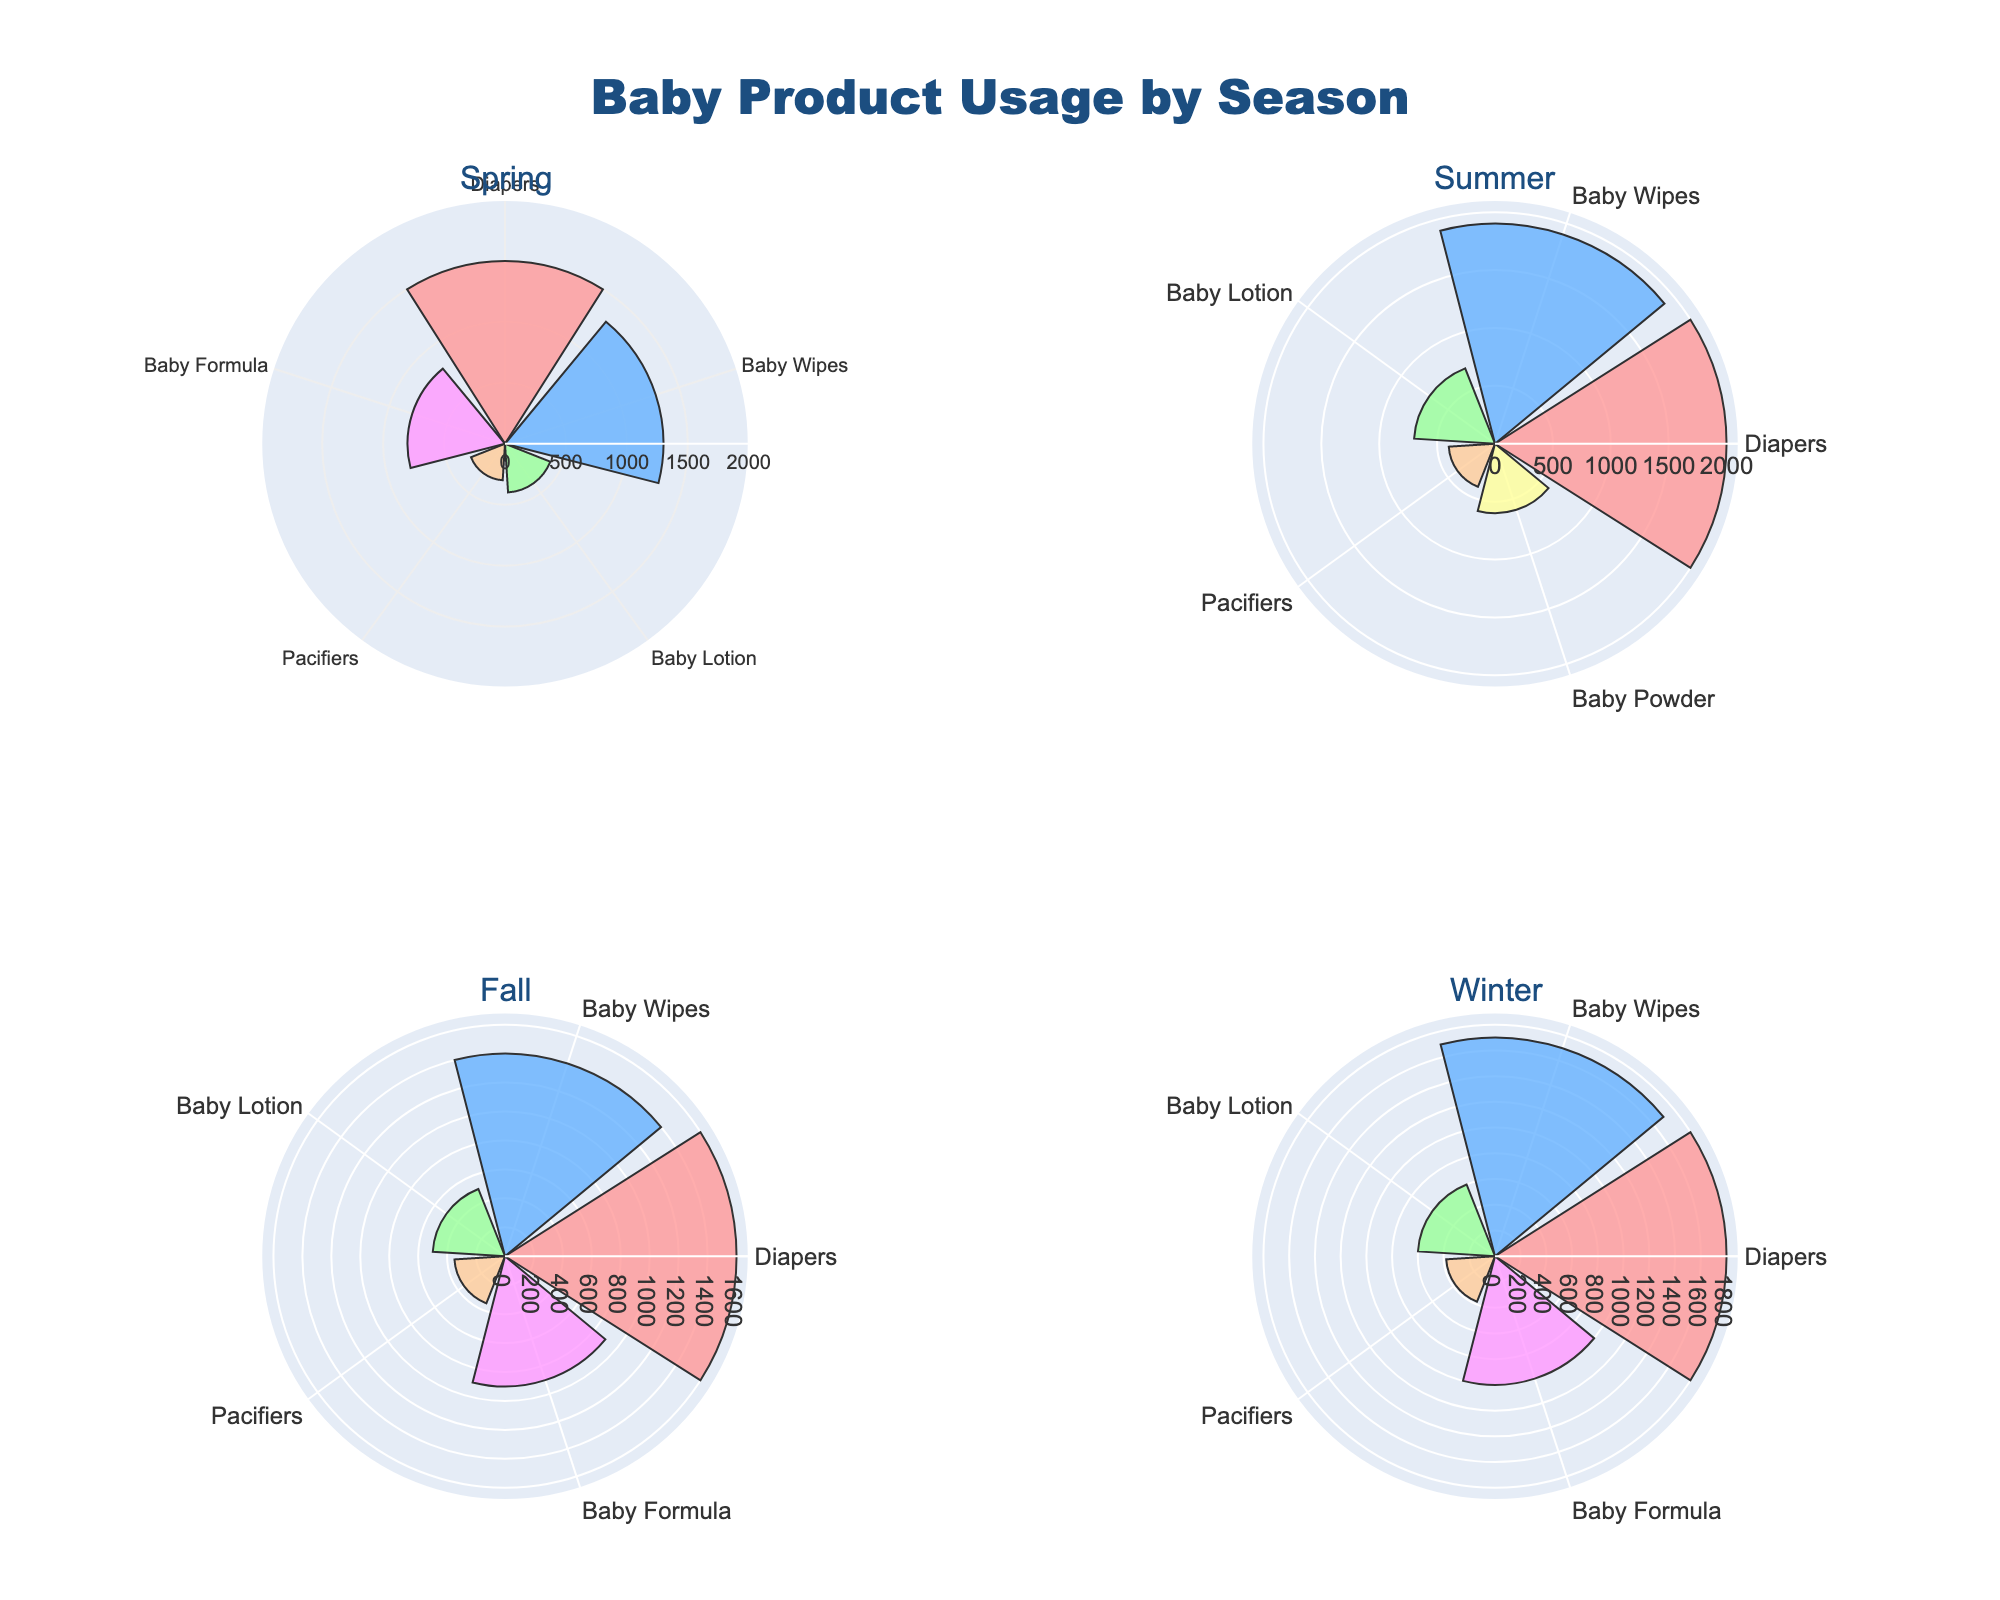What is the title of the figure? The title of the figure is typically displayed at the top and provides a summary of the content being depicted. Here, the title "Baby Product Usage by Season" is clearly shown.
Answer: "Baby Product Usage by Season" Which baby product has the highest usage count in summer? In the summer polar plot, the product with the longest bar is "Diapers," indicating it has the highest usage count.
Answer: Diapers What is the combined usage count of Baby Formula in Spring and Winter? In Spring, Baby Formula has a usage count of 800. In Winter, Baby Formula has a usage count of 1000. Summing these values gives 800 + 1000 = 1800.
Answer: 1800 Which product usage showed the most consistent trend across all seasons? Diapers have high and relatively consistent usage counts in all seasons, visualized by their consistently long bars across all subplots.
Answer: Diapers Is Baby Lotion used more in Summer or Winter? In the polar plots, the bar for Baby Lotion is longer in Summer than in Winter, indicating higher usage in Summer.
Answer: Summer What is the smallest usage count for any baby product in Fall? By visually inspecting the Fall subplot, the smallest bar corresponds to Pacifiers with a usage count of 350.
Answer: 350 Which season has the highest usage for baby wipes? The longest bar for Baby Wipes is seen in the Summer subplot, indicating that summer has the highest usage count.
Answer: Summer What is the total usage count of Pacifiers across all seasons? By adding up the usage counts of Pacifiers in each season: 300 (Spring) + 400 (Summer) + 350 (Fall) + 380 (Winter) = 1430.
Answer: 1430 Which season has the lowest combined usage count of all baby products? By visually inspecting the subplots, Spring has shorter bars overall compared to other seasons, which implies it may have the lowest total usage count.
Answer: Spring 